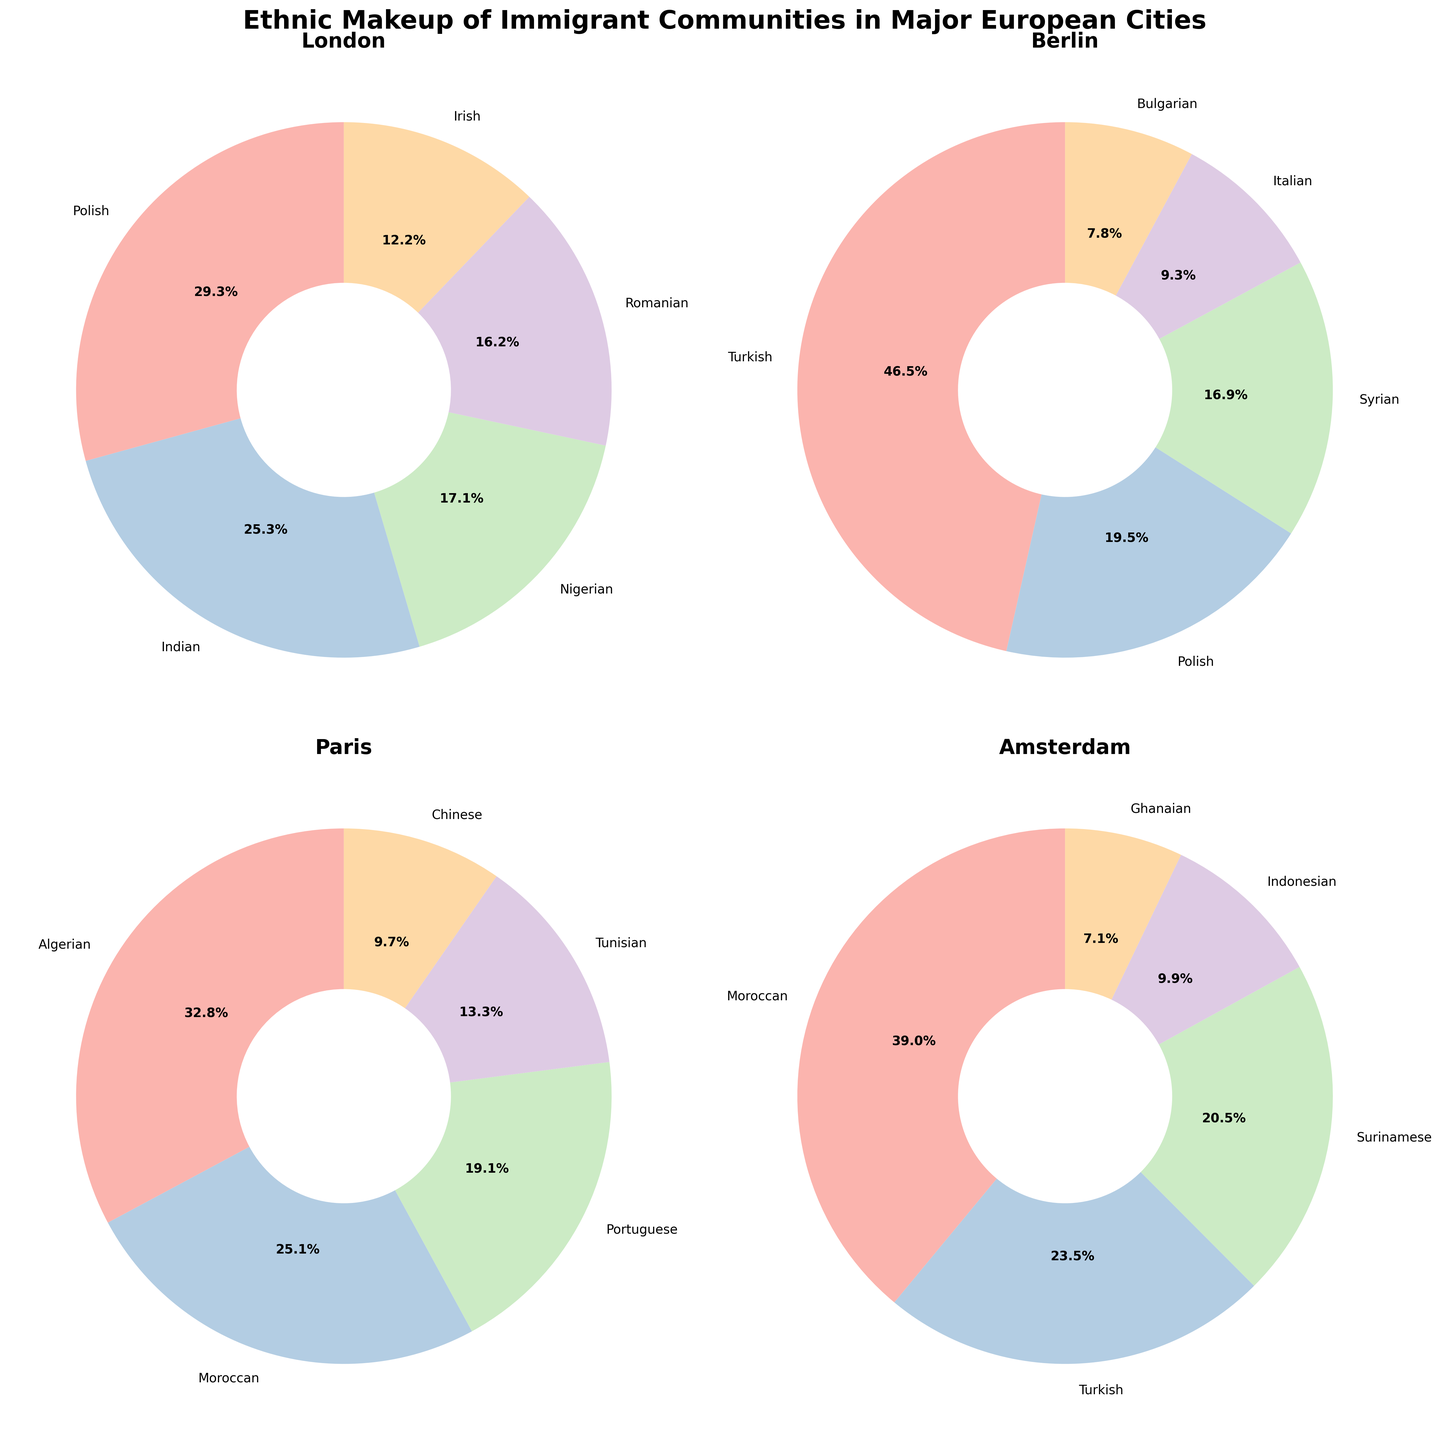What is the most common ethnic group in Berlin? To identify the most common ethnic group in Berlin, observe the segment with the largest percentage in the pie chart representing Berlin. The Turkish ethnic group has the largest segment, occupying 23.1%.
Answer: Turkish Which city has the highest percentage of Polish immigrants? Compare the percentages of Polish immigrants across all cities from their respective pie charts. London has 12.5%, Berlin has 9.7%, Paris has no Polish immigrants, and Amsterdam has none as well. Therefore, London has the highest percentage of Polish immigrants.
Answer: London What is the combined percentage of Indian and Nigerian communities in London? To find the combined percentage, sum the individual percentages of the Indian and Nigerian communities in London. Indian is 10.8% and Nigerian is 7.3%. Adding them together, 10.8% + 7.3% = 18.1%.
Answer: 18.1% How does the percentage of the Moroccan community in Amsterdam compare to that in Paris? Compare the corresponding segments for Moroccan communities in Amsterdam and Paris. Amsterdam has a 18.6% Moroccan community whereas Paris has 11.7%. Therefore, Amsterdam has a higher percentage of Moroccan immigrants.
Answer: Amsterdam has a higher percentage Which ethnic group in Paris has the smallest representation? Locate the smallest segment in the Paris pie chart. The Chinese community represents the smallest percentage, which is 4.5%.
Answer: Chinese How many ethnic groups in Berlin have percentages less than 10%? Identify and count the segments in Berlin's pie chart that are less than 10%. The groups are Polish (9.7%), Syrian (8.4%), Italian (4.6%), and Bulgarian (3.9%), thus a total of 4 ethnic groups.
Answer: 4 What is the percentage difference between the largest ethnic group in London and the largest ethnic group in Amsterdam? Identify the largest ethnic groups in both London and Amsterdam, then calculate the percentage difference. London's largest is the Polish community at 12.5%, and Amsterdam’s is the Moroccan community at 18.6%. The difference is 18.6% - 12.5% = 6.1%.
Answer: 6.1% Which city has the highest diversity of ethnic groups represented (i.e., the most different ethnic groups)? Count the number of distinct ethnic groups represented in each city's pie chart. London, Berlin, and Paris each have 5 groups, whereas Amsterdam also has 5 groups. Thus, all cities have the same diversity in terms of the number of different ethnic groups.
Answer: All cities have the same diversity 